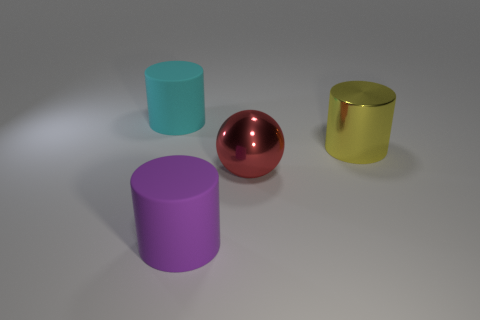What number of red spheres are made of the same material as the yellow object?
Make the answer very short. 1. How many large yellow metal objects are in front of the large cylinder that is in front of the large yellow metal cylinder?
Provide a short and direct response. 0. How many tiny red shiny balls are there?
Your response must be concise. 0. Does the large cyan thing have the same material as the cylinder that is to the right of the purple cylinder?
Your answer should be compact. No. There is a rubber cylinder that is left of the purple matte cylinder; does it have the same color as the metallic cylinder?
Offer a terse response. No. What material is the big cylinder that is both behind the purple matte thing and to the right of the cyan matte cylinder?
Ensure brevity in your answer.  Metal. The red sphere has what size?
Keep it short and to the point. Large. There is a large shiny cylinder; does it have the same color as the big matte thing behind the large red metallic object?
Make the answer very short. No. How many other objects are the same color as the metal cylinder?
Your response must be concise. 0. Does the matte cylinder behind the ball have the same size as the rubber cylinder in front of the yellow metallic object?
Give a very brief answer. Yes. 